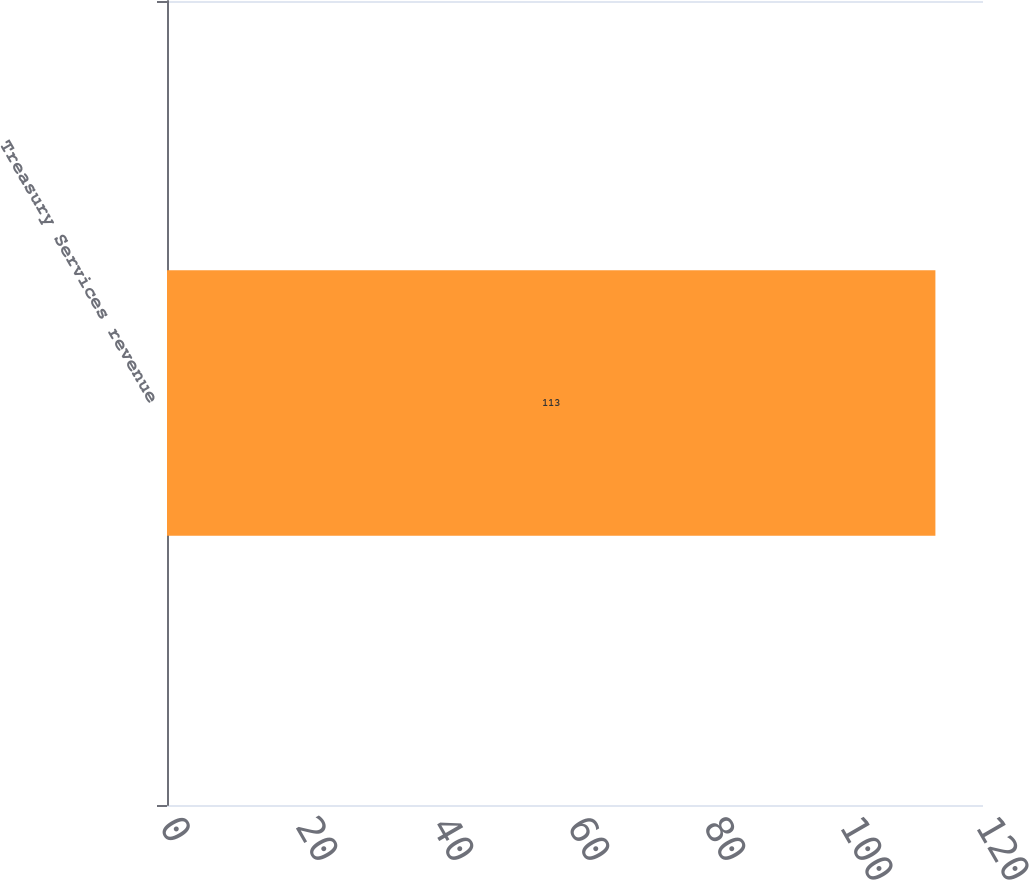Convert chart. <chart><loc_0><loc_0><loc_500><loc_500><bar_chart><fcel>Treasury Services revenue<nl><fcel>113<nl></chart> 